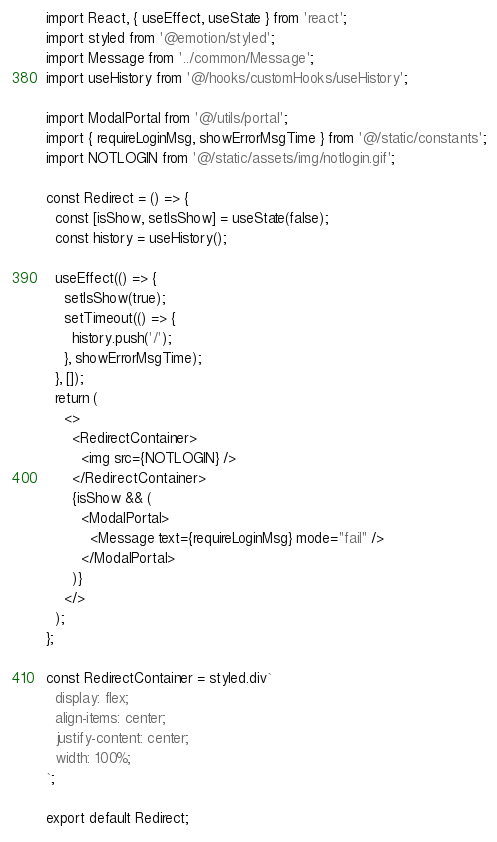<code> <loc_0><loc_0><loc_500><loc_500><_TypeScript_>import React, { useEffect, useState } from 'react';
import styled from '@emotion/styled';
import Message from '../common/Message';
import useHistory from '@/hooks/customHooks/useHistory';

import ModalPortal from '@/utils/portal';
import { requireLoginMsg, showErrorMsgTime } from '@/static/constants';
import NOTLOGIN from '@/static/assets/img/notlogin.gif';

const Redirect = () => {
  const [isShow, setIsShow] = useState(false);
  const history = useHistory();

  useEffect(() => {
    setIsShow(true);
    setTimeout(() => {
      history.push('/');
    }, showErrorMsgTime);
  }, []);
  return (
    <>
      <RedirectContainer>
        <img src={NOTLOGIN} />
      </RedirectContainer>
      {isShow && (
        <ModalPortal>
          <Message text={requireLoginMsg} mode="fail" />
        </ModalPortal>
      )}
    </>
  );
};

const RedirectContainer = styled.div`
  display: flex;
  align-items: center;
  justify-content: center;
  width: 100%;
`;

export default Redirect;
</code> 